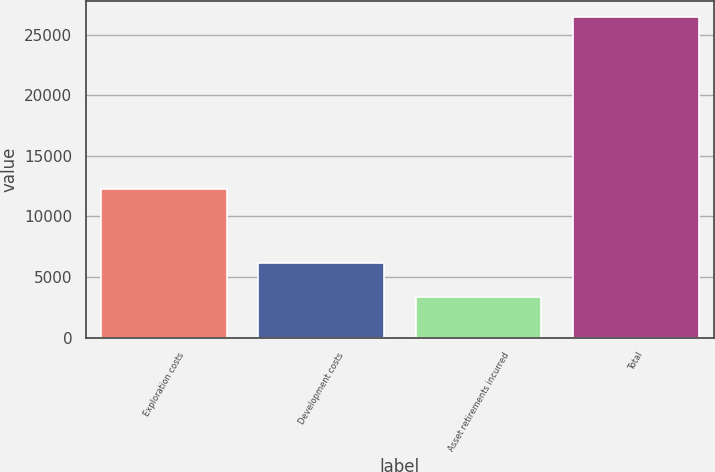<chart> <loc_0><loc_0><loc_500><loc_500><bar_chart><fcel>Exploration costs<fcel>Development costs<fcel>Asset retirements incurred<fcel>Total<nl><fcel>12256<fcel>6144<fcel>3365<fcel>26416<nl></chart> 